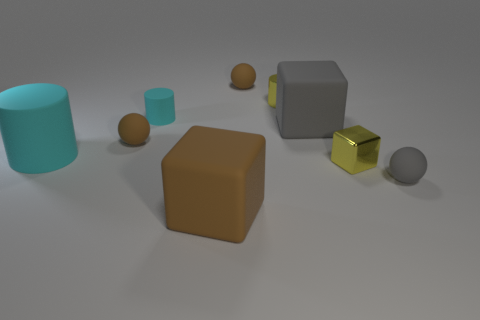Is the shape of the small gray rubber thing the same as the brown thing that is in front of the small yellow block?
Ensure brevity in your answer.  No. How many other objects are there of the same material as the yellow cylinder?
Offer a terse response. 1. There is a large cylinder; does it have the same color as the big matte block that is to the left of the yellow shiny cylinder?
Offer a very short reply. No. There is a big block in front of the gray matte sphere; what is its material?
Provide a succinct answer. Rubber. Are there any small things that have the same color as the small shiny cube?
Your response must be concise. Yes. There is a rubber cylinder that is the same size as the yellow block; what is its color?
Provide a succinct answer. Cyan. How many small objects are either red cylinders or gray rubber things?
Your answer should be very brief. 1. Is the number of large gray matte blocks to the left of the large cyan matte thing the same as the number of cylinders that are to the right of the big brown object?
Ensure brevity in your answer.  No. What number of spheres are the same size as the metal cube?
Give a very brief answer. 3. How many gray things are large objects or tiny rubber spheres?
Your answer should be very brief. 2. 